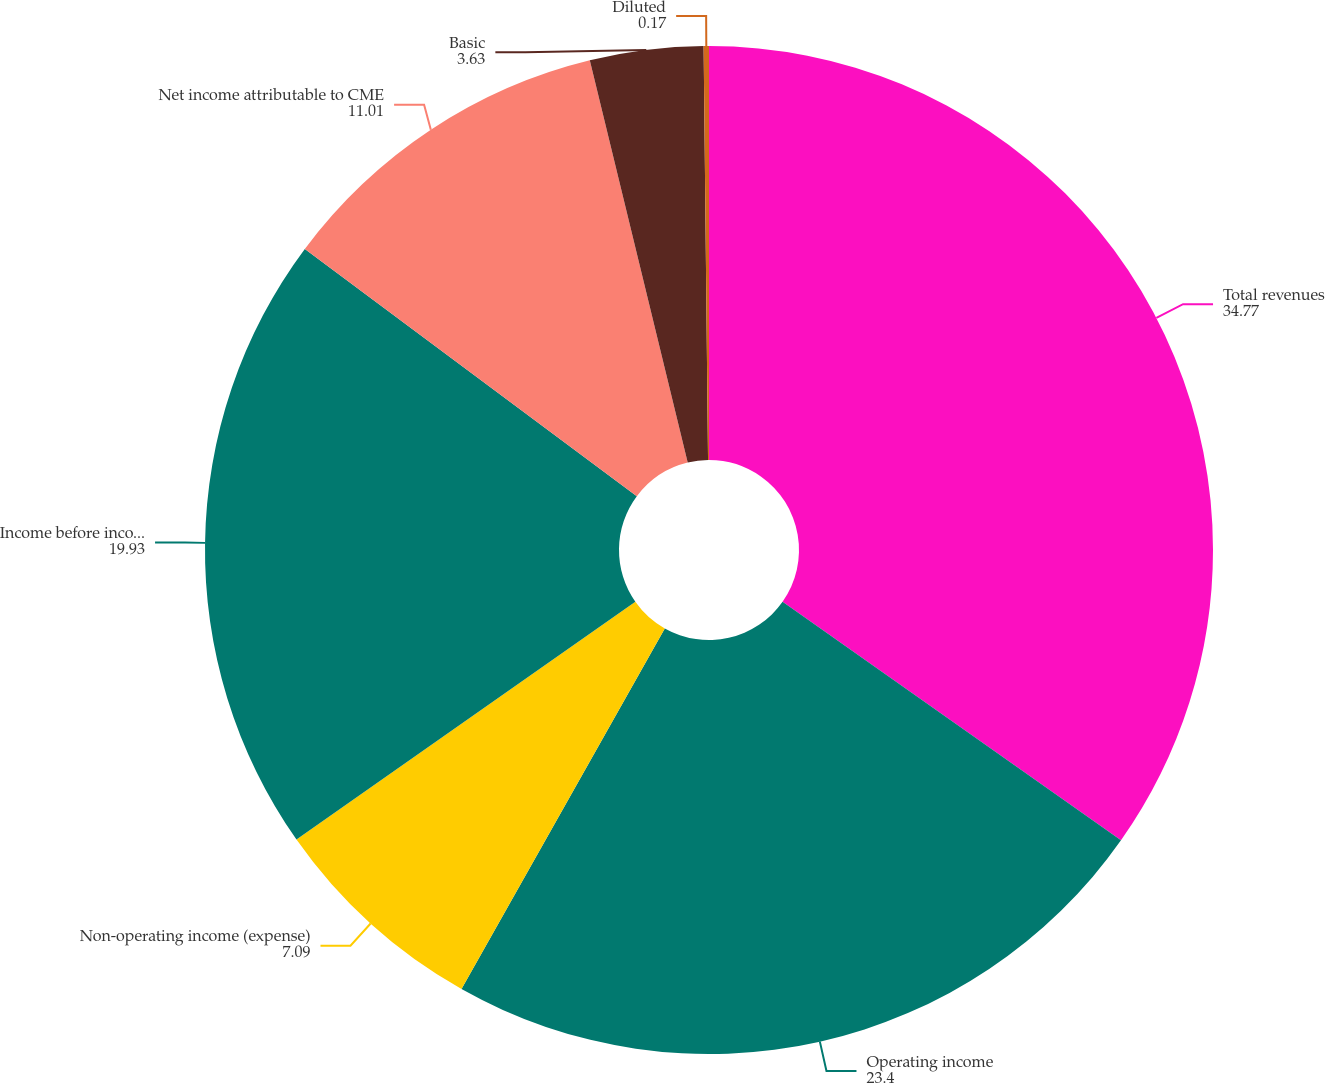<chart> <loc_0><loc_0><loc_500><loc_500><pie_chart><fcel>Total revenues<fcel>Operating income<fcel>Non-operating income (expense)<fcel>Income before income taxes<fcel>Net income attributable to CME<fcel>Basic<fcel>Diluted<nl><fcel>34.77%<fcel>23.4%<fcel>7.09%<fcel>19.93%<fcel>11.01%<fcel>3.63%<fcel>0.17%<nl></chart> 